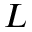<formula> <loc_0><loc_0><loc_500><loc_500>L</formula> 